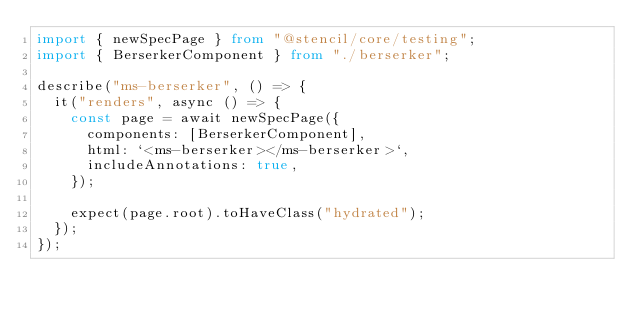<code> <loc_0><loc_0><loc_500><loc_500><_TypeScript_>import { newSpecPage } from "@stencil/core/testing";
import { BerserkerComponent } from "./berserker";

describe("ms-berserker", () => {
  it("renders", async () => {
    const page = await newSpecPage({
      components: [BerserkerComponent],
      html: `<ms-berserker></ms-berserker>`,
      includeAnnotations: true,
    });

    expect(page.root).toHaveClass("hydrated");
  });
});
</code> 